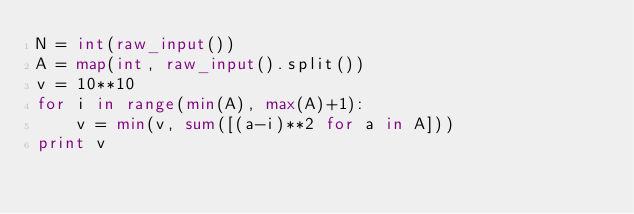Convert code to text. <code><loc_0><loc_0><loc_500><loc_500><_Python_>N = int(raw_input())
A = map(int, raw_input().split())
v = 10**10
for i in range(min(A), max(A)+1):
    v = min(v, sum([(a-i)**2 for a in A]))
print v
</code> 